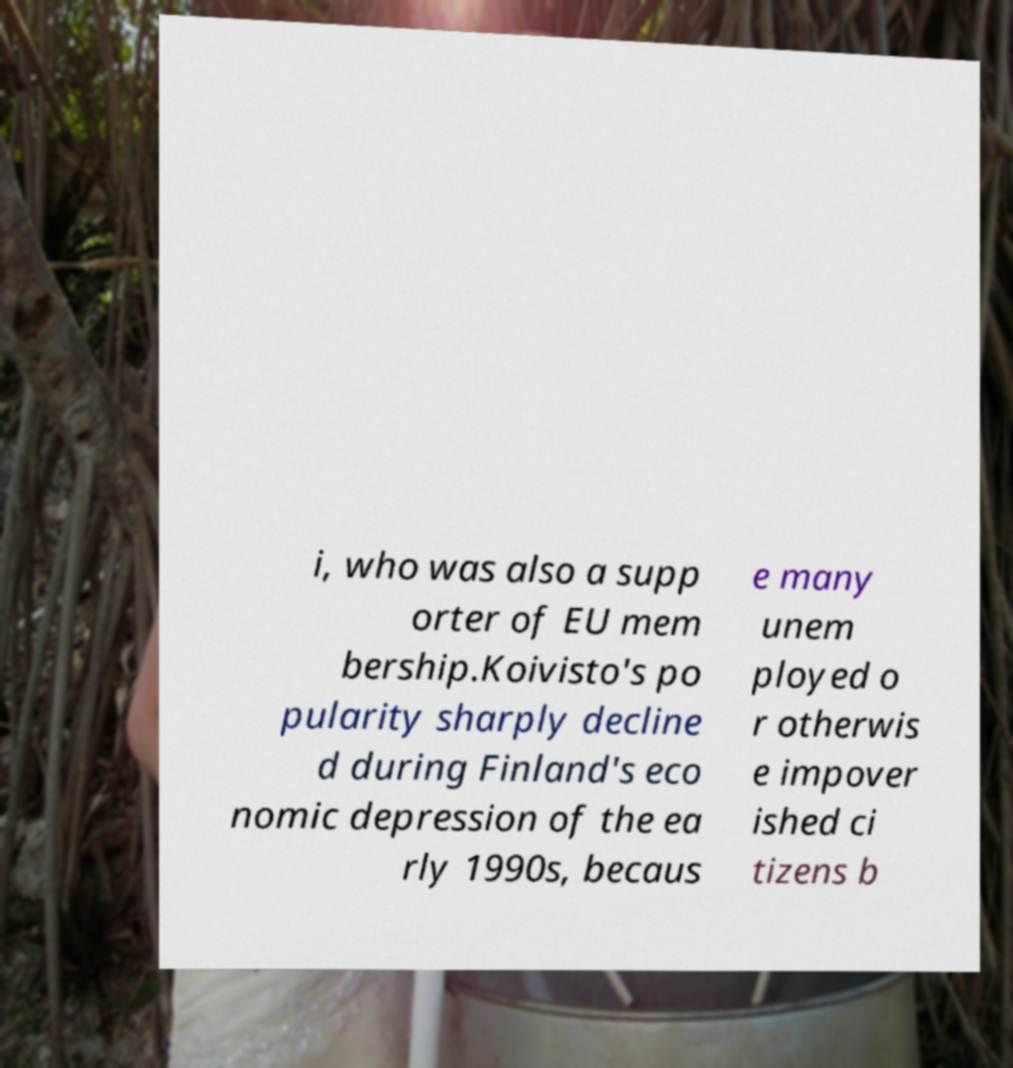Could you assist in decoding the text presented in this image and type it out clearly? i, who was also a supp orter of EU mem bership.Koivisto's po pularity sharply decline d during Finland's eco nomic depression of the ea rly 1990s, becaus e many unem ployed o r otherwis e impover ished ci tizens b 